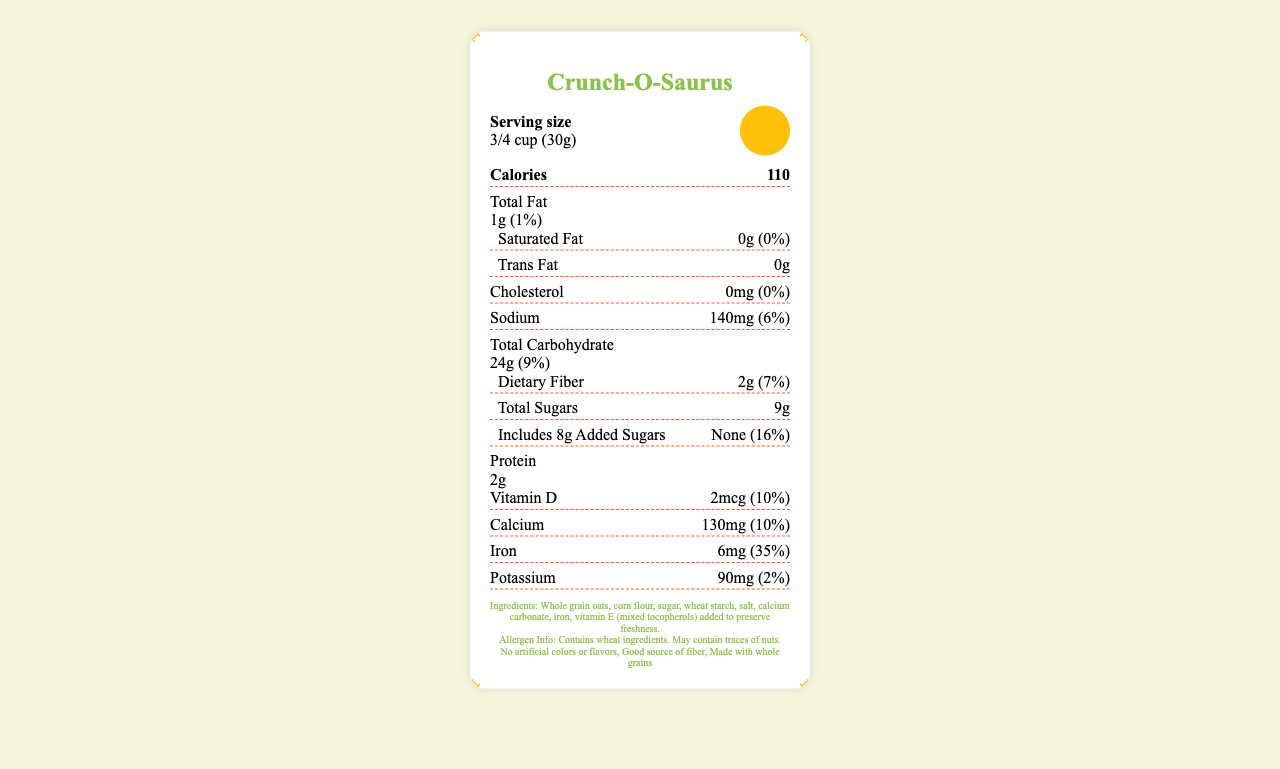what is the serving size of Crunch-O-Saurus cereal? The serving size is stated in both text and visually depicted with a cartoon dinosaur holding a measuring cup.
Answer: 3/4 cup (30g) how many servings are in a container? The number of servings per container is listed as "About 12" on the label.
Answer: About 12 what type of fat is completely absent in this cereal? The label shows that both Saturated Fat and Trans Fat have 0g per serving.
Answer: Saturated Fat and Trans Fat how many grams of total sugars are in one serving? The total sugars per serving is listed as 9g on the label.
Answer: 9g what amount of Vitamin D is present in one serving? The label indicates that each serving contains 2mcg of Vitamin D.
Answer: 2mcg which ingredient helps preserve freshness? A. Whole grain oats B. Iron C. Vitamin E The ingredients list includes "vitamin E (mixed tocopherols) added to preserve freshness."
Answer: C what is the color scheme used on the packaging? A. #8BC34A, #FFC107, #FF5722 B. #FF0000, #00FF00, #0000FF C. #FFFFFF, #AAAAAA, #CCCCCC The document specifies the color scheme: primary (#8BC34A), secondary (#FFC107), and accent (#FF5722).
Answer: A is there cholesterol in this cereal? The label indicates that the cholesterol amount is 0mg per serving.
Answer: No are there any certifications for this product? The certifications listed include "Non-GMO Project Verified" and "Whole Grain Council Stamp."
Answer: Non-GMO Project Verified and Whole Grain Council Stamp does this cereal contain any allergens? The allergen information states that it contains wheat ingredients and may contain traces of nuts.
Answer: Yes what special packaging feature is highlighted? The document mentions the packaging material as "100% recycled paperboard with soy-based inks."
Answer: 100% recycled paperboard with soy-based inks what is the main idea of the document? The document is designed to attract children and parents by incorporating playful elements like cartoon illustrations and unique fonts while providing comprehensive nutritional information and highlighting its eco-friendly and health-conscious features.
Answer: The document provides detailed nutritional information and visually appealing features of "Crunch-O-Saurus" cereal aimed at children, focusing on its serving size, calories, nutrient content, ingredients, and certifications. what is the daily value percentage of iron per serving? The label shows that the iron amount per serving is 6mg, which is 35% of the daily value.
Answer: 35% how many calories does one serving contain? The label indicates that each serving contains 110 calories.
Answer: 110 is "good source of fiber" a marketing claim for this product? "Good source of fiber" is listed among the marketing claims on the label.
Answer: Yes is the recycling process for the packaging discussed in detail? While the packaging is noted to be made from 100% recycled paperboard with soy-based inks, the specific recycling process is not detailed in the given information.
Answer: Not enough information 